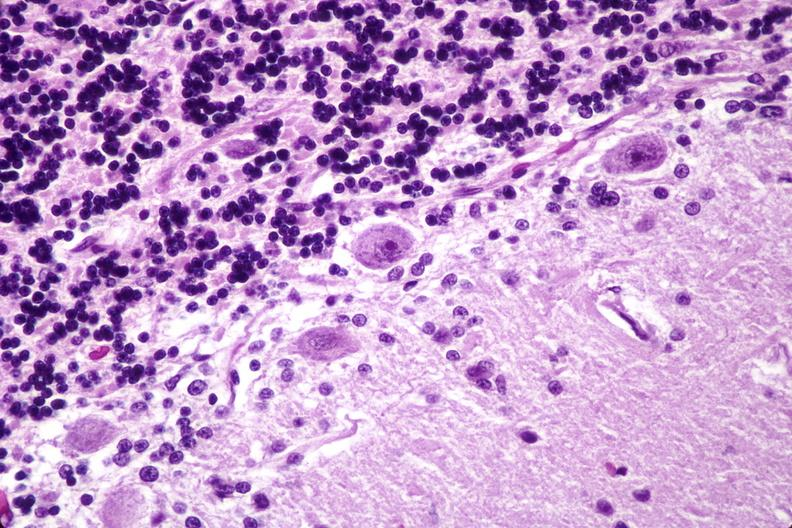what is present?
Answer the question using a single word or phrase. Nervous 